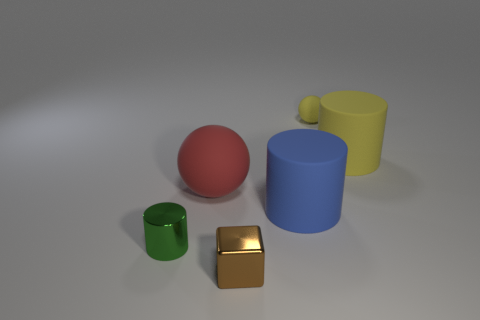Subtract all big blue cylinders. How many cylinders are left? 2 Add 2 small yellow rubber balls. How many objects exist? 8 Subtract all red spheres. How many spheres are left? 1 Subtract all cubes. How many objects are left? 5 Subtract 1 cylinders. How many cylinders are left? 2 Subtract all tiny brown shiny blocks. Subtract all blue rubber cylinders. How many objects are left? 4 Add 2 large matte objects. How many large matte objects are left? 5 Add 3 red rubber objects. How many red rubber objects exist? 4 Subtract 0 gray spheres. How many objects are left? 6 Subtract all purple cylinders. Subtract all purple blocks. How many cylinders are left? 3 